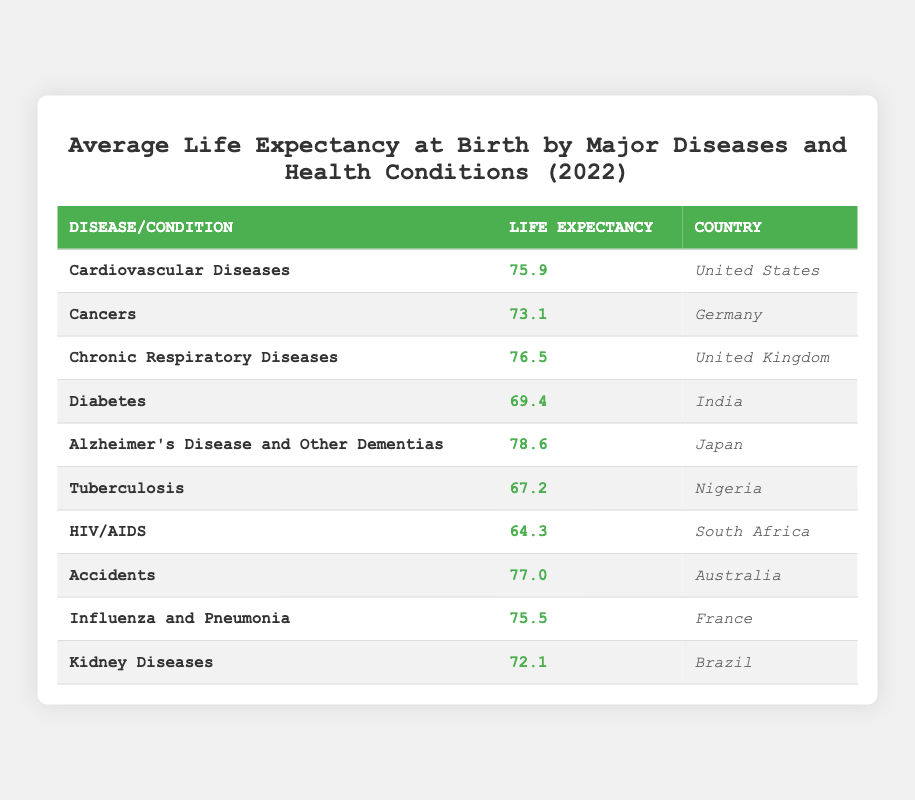What is the life expectancy for individuals suffering from Alzheimer's Disease and Other Dementias in Japan? The table lists Alzheimer's Disease and Other Dementias with a life expectancy of 78.6 years under the country Japan.
Answer: 78.6 Which disease has the lowest life expectancy in South Africa? According to the table, HIV/AIDS has a life expectancy of 64.3 years, which is the lowest for South Africa compared to other diseases listed.
Answer: HIV/AIDS What is the average life expectancy for individuals suffering from Chronic Respiratory Diseases and Accidents combined in the United Kingdom and Australia? Chronic Respiratory Diseases has a life expectancy of 76.5 years in the United Kingdom, while Accidents has a life expectancy of 77.0 years in Australia. The sum of both is 76.5 + 77.0 = 153.5, and the average is 153.5/2 = 76.75.
Answer: 76.75 Is the life expectancy for Cancers in Germany greater or less than 74 years? The table shows that the life expectancy for Cancers in Germany is 73.1 years, which is less than 74 years.
Answer: No Which country has a greater life expectancy among those suffering from Tuberculosis and Diabetes, and what are the respective values? For Tuberculosis, Nigeria has a life expectancy of 67.2 years. For Diabetes, India has a life expectancy of 69.4 years. Since 69.4 is greater than 67.2, India has a greater life expectancy.
Answer: India with 69.4 What is the total life expectancy of individuals suffering from Cardiovascular Diseases and Influenza and Pneumonia in the United States and France? In the United States, Cardiovascular Diseases has a life expectancy of 75.9 years. In France, Influenza and Pneumonia has a life expectancy of 75.5 years. The total is 75.9 + 75.5 = 151.4.
Answer: 151.4 What is the life expectancy for Chronic Respiratory Diseases in the United Kingdom compared to the life expectancy for Diabetes in India? The life expectancy for Chronic Respiratory Diseases in the United Kingdom is 76.5 years, while for Diabetes in India, it is 69.4 years. Since 76.5 is greater than 69.4, Chronic Respiratory Diseases has a higher life expectancy.
Answer: Greater How many diseases in this table have a life expectancy below 70 years? The diseases with a life expectancy below 70 years are Diabetes (69.4), Tuberculosis (67.2), and HIV/AIDS (64.3). Therefore, there are 3 diseases below 70 years.
Answer: 3 